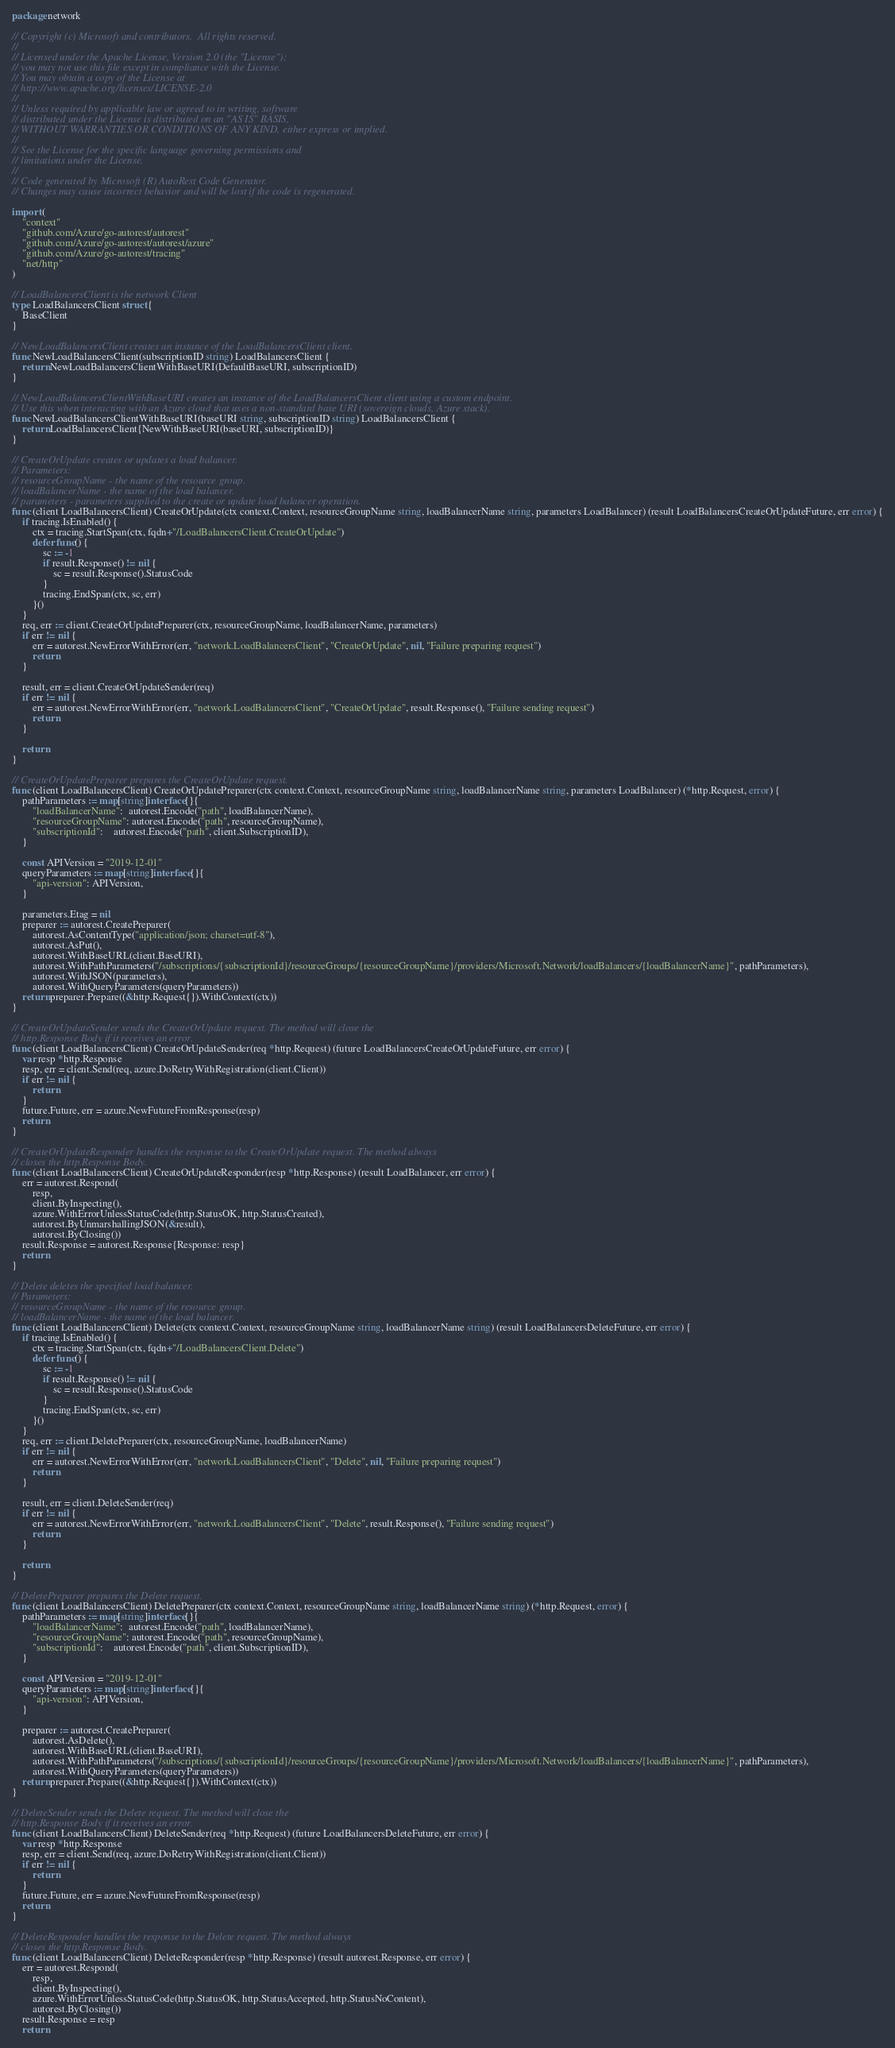<code> <loc_0><loc_0><loc_500><loc_500><_Go_>package network

// Copyright (c) Microsoft and contributors.  All rights reserved.
//
// Licensed under the Apache License, Version 2.0 (the "License");
// you may not use this file except in compliance with the License.
// You may obtain a copy of the License at
// http://www.apache.org/licenses/LICENSE-2.0
//
// Unless required by applicable law or agreed to in writing, software
// distributed under the License is distributed on an "AS IS" BASIS,
// WITHOUT WARRANTIES OR CONDITIONS OF ANY KIND, either express or implied.
//
// See the License for the specific language governing permissions and
// limitations under the License.
//
// Code generated by Microsoft (R) AutoRest Code Generator.
// Changes may cause incorrect behavior and will be lost if the code is regenerated.

import (
	"context"
	"github.com/Azure/go-autorest/autorest"
	"github.com/Azure/go-autorest/autorest/azure"
	"github.com/Azure/go-autorest/tracing"
	"net/http"
)

// LoadBalancersClient is the network Client
type LoadBalancersClient struct {
	BaseClient
}

// NewLoadBalancersClient creates an instance of the LoadBalancersClient client.
func NewLoadBalancersClient(subscriptionID string) LoadBalancersClient {
	return NewLoadBalancersClientWithBaseURI(DefaultBaseURI, subscriptionID)
}

// NewLoadBalancersClientWithBaseURI creates an instance of the LoadBalancersClient client using a custom endpoint.
// Use this when interacting with an Azure cloud that uses a non-standard base URI (sovereign clouds, Azure stack).
func NewLoadBalancersClientWithBaseURI(baseURI string, subscriptionID string) LoadBalancersClient {
	return LoadBalancersClient{NewWithBaseURI(baseURI, subscriptionID)}
}

// CreateOrUpdate creates or updates a load balancer.
// Parameters:
// resourceGroupName - the name of the resource group.
// loadBalancerName - the name of the load balancer.
// parameters - parameters supplied to the create or update load balancer operation.
func (client LoadBalancersClient) CreateOrUpdate(ctx context.Context, resourceGroupName string, loadBalancerName string, parameters LoadBalancer) (result LoadBalancersCreateOrUpdateFuture, err error) {
	if tracing.IsEnabled() {
		ctx = tracing.StartSpan(ctx, fqdn+"/LoadBalancersClient.CreateOrUpdate")
		defer func() {
			sc := -1
			if result.Response() != nil {
				sc = result.Response().StatusCode
			}
			tracing.EndSpan(ctx, sc, err)
		}()
	}
	req, err := client.CreateOrUpdatePreparer(ctx, resourceGroupName, loadBalancerName, parameters)
	if err != nil {
		err = autorest.NewErrorWithError(err, "network.LoadBalancersClient", "CreateOrUpdate", nil, "Failure preparing request")
		return
	}

	result, err = client.CreateOrUpdateSender(req)
	if err != nil {
		err = autorest.NewErrorWithError(err, "network.LoadBalancersClient", "CreateOrUpdate", result.Response(), "Failure sending request")
		return
	}

	return
}

// CreateOrUpdatePreparer prepares the CreateOrUpdate request.
func (client LoadBalancersClient) CreateOrUpdatePreparer(ctx context.Context, resourceGroupName string, loadBalancerName string, parameters LoadBalancer) (*http.Request, error) {
	pathParameters := map[string]interface{}{
		"loadBalancerName":  autorest.Encode("path", loadBalancerName),
		"resourceGroupName": autorest.Encode("path", resourceGroupName),
		"subscriptionId":    autorest.Encode("path", client.SubscriptionID),
	}

	const APIVersion = "2019-12-01"
	queryParameters := map[string]interface{}{
		"api-version": APIVersion,
	}

	parameters.Etag = nil
	preparer := autorest.CreatePreparer(
		autorest.AsContentType("application/json; charset=utf-8"),
		autorest.AsPut(),
		autorest.WithBaseURL(client.BaseURI),
		autorest.WithPathParameters("/subscriptions/{subscriptionId}/resourceGroups/{resourceGroupName}/providers/Microsoft.Network/loadBalancers/{loadBalancerName}", pathParameters),
		autorest.WithJSON(parameters),
		autorest.WithQueryParameters(queryParameters))
	return preparer.Prepare((&http.Request{}).WithContext(ctx))
}

// CreateOrUpdateSender sends the CreateOrUpdate request. The method will close the
// http.Response Body if it receives an error.
func (client LoadBalancersClient) CreateOrUpdateSender(req *http.Request) (future LoadBalancersCreateOrUpdateFuture, err error) {
	var resp *http.Response
	resp, err = client.Send(req, azure.DoRetryWithRegistration(client.Client))
	if err != nil {
		return
	}
	future.Future, err = azure.NewFutureFromResponse(resp)
	return
}

// CreateOrUpdateResponder handles the response to the CreateOrUpdate request. The method always
// closes the http.Response Body.
func (client LoadBalancersClient) CreateOrUpdateResponder(resp *http.Response) (result LoadBalancer, err error) {
	err = autorest.Respond(
		resp,
		client.ByInspecting(),
		azure.WithErrorUnlessStatusCode(http.StatusOK, http.StatusCreated),
		autorest.ByUnmarshallingJSON(&result),
		autorest.ByClosing())
	result.Response = autorest.Response{Response: resp}
	return
}

// Delete deletes the specified load balancer.
// Parameters:
// resourceGroupName - the name of the resource group.
// loadBalancerName - the name of the load balancer.
func (client LoadBalancersClient) Delete(ctx context.Context, resourceGroupName string, loadBalancerName string) (result LoadBalancersDeleteFuture, err error) {
	if tracing.IsEnabled() {
		ctx = tracing.StartSpan(ctx, fqdn+"/LoadBalancersClient.Delete")
		defer func() {
			sc := -1
			if result.Response() != nil {
				sc = result.Response().StatusCode
			}
			tracing.EndSpan(ctx, sc, err)
		}()
	}
	req, err := client.DeletePreparer(ctx, resourceGroupName, loadBalancerName)
	if err != nil {
		err = autorest.NewErrorWithError(err, "network.LoadBalancersClient", "Delete", nil, "Failure preparing request")
		return
	}

	result, err = client.DeleteSender(req)
	if err != nil {
		err = autorest.NewErrorWithError(err, "network.LoadBalancersClient", "Delete", result.Response(), "Failure sending request")
		return
	}

	return
}

// DeletePreparer prepares the Delete request.
func (client LoadBalancersClient) DeletePreparer(ctx context.Context, resourceGroupName string, loadBalancerName string) (*http.Request, error) {
	pathParameters := map[string]interface{}{
		"loadBalancerName":  autorest.Encode("path", loadBalancerName),
		"resourceGroupName": autorest.Encode("path", resourceGroupName),
		"subscriptionId":    autorest.Encode("path", client.SubscriptionID),
	}

	const APIVersion = "2019-12-01"
	queryParameters := map[string]interface{}{
		"api-version": APIVersion,
	}

	preparer := autorest.CreatePreparer(
		autorest.AsDelete(),
		autorest.WithBaseURL(client.BaseURI),
		autorest.WithPathParameters("/subscriptions/{subscriptionId}/resourceGroups/{resourceGroupName}/providers/Microsoft.Network/loadBalancers/{loadBalancerName}", pathParameters),
		autorest.WithQueryParameters(queryParameters))
	return preparer.Prepare((&http.Request{}).WithContext(ctx))
}

// DeleteSender sends the Delete request. The method will close the
// http.Response Body if it receives an error.
func (client LoadBalancersClient) DeleteSender(req *http.Request) (future LoadBalancersDeleteFuture, err error) {
	var resp *http.Response
	resp, err = client.Send(req, azure.DoRetryWithRegistration(client.Client))
	if err != nil {
		return
	}
	future.Future, err = azure.NewFutureFromResponse(resp)
	return
}

// DeleteResponder handles the response to the Delete request. The method always
// closes the http.Response Body.
func (client LoadBalancersClient) DeleteResponder(resp *http.Response) (result autorest.Response, err error) {
	err = autorest.Respond(
		resp,
		client.ByInspecting(),
		azure.WithErrorUnlessStatusCode(http.StatusOK, http.StatusAccepted, http.StatusNoContent),
		autorest.ByClosing())
	result.Response = resp
	return</code> 